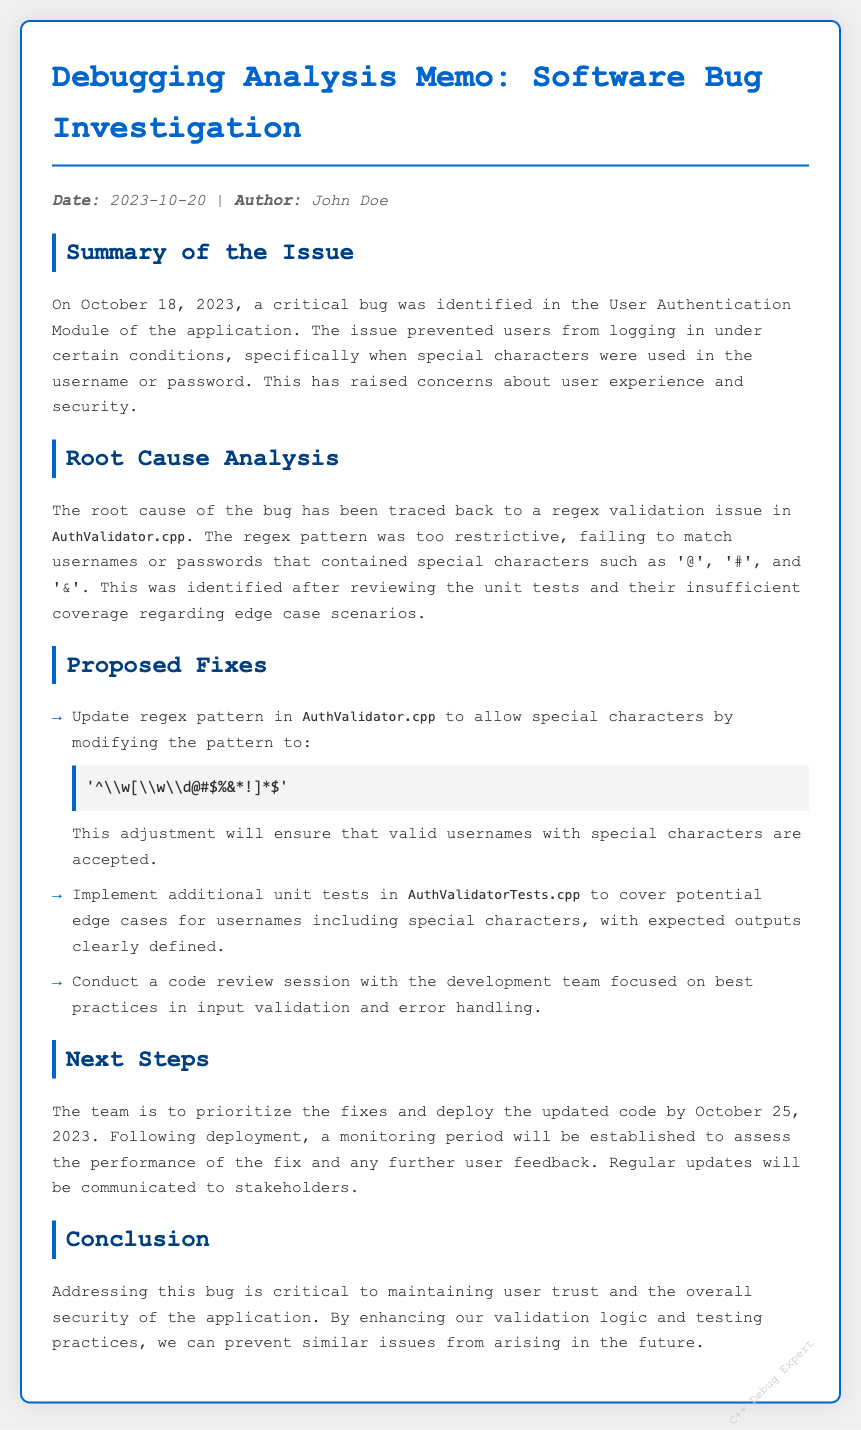what is the date of the memo? The date of the memo is explicitly stated in the meta info section of the document.
Answer: 2023-10-20 who is the author of the memo? The author's name is provided in the meta info section of the document.
Answer: John Doe what module was affected by the bug? The affected module is mentioned in the summary section of the document.
Answer: User Authentication Module what was the root cause of the bug? The root cause is detailed in the root cause analysis section, outlining the specific problem.
Answer: regex validation issue what is the proposed regex pattern for username validation? The proposed regex pattern is presented in the proposed fixes section of the document.
Answer: ^\w[\w\d@#$%&*!]*$ what is one of the next steps after the proposed fixes? One of the next steps is specified in the next steps section of the document.
Answer: deploy the updated code by October 25, 2023 what should be conducted to enhance input validation practices? A recommendation for improving practices is mentioned in the proposed fixes section.
Answer: code review session why is addressing the bug important? The importance of addressing the bug is summarized in the conclusion section of the document.
Answer: maintaining user trust and security how can similar issues be prevented in the future? The method for preventing similar issues is suggested in the conclusion section.
Answer: enhancing validation logic and testing practices 